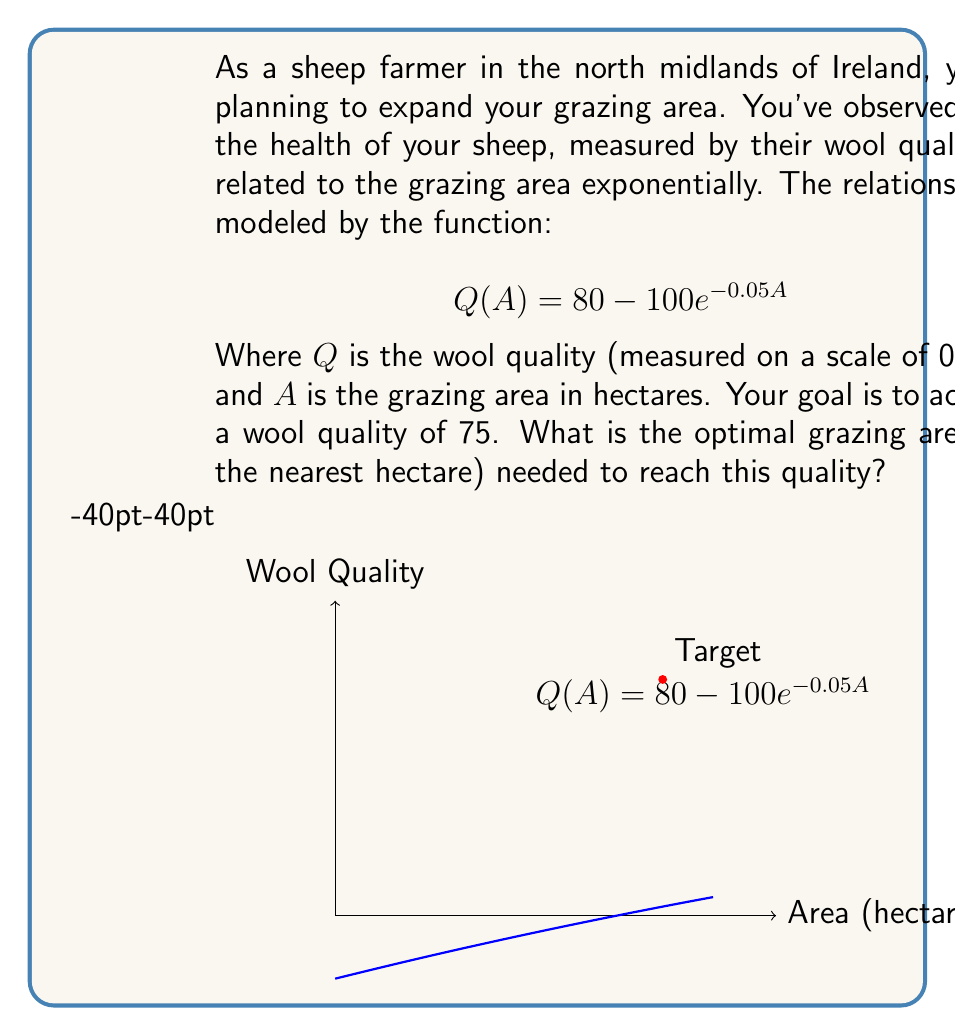Can you solve this math problem? Let's approach this step-by-step:

1) We need to solve the equation:
   $$75 = 80 - 100e^{-0.05A}$$

2) Subtract 80 from both sides:
   $$-5 = -100e^{-0.05A}$$

3) Divide both sides by -100:
   $$0.05 = e^{-0.05A}$$

4) Take the natural logarithm of both sides:
   $$\ln(0.05) = -0.05A$$

5) Solve for A:
   $$A = \frac{-\ln(0.05)}{0.05}$$

6) Calculate the value:
   $$A = \frac{-(-2.9957)}{0.05} = 59.914$$

7) Rounding to the nearest hectare:
   $$A \approx 42$$ hectares

Therefore, the optimal grazing area needed to achieve a wool quality of 75 is approximately 42 hectares.
Answer: 42 hectares 